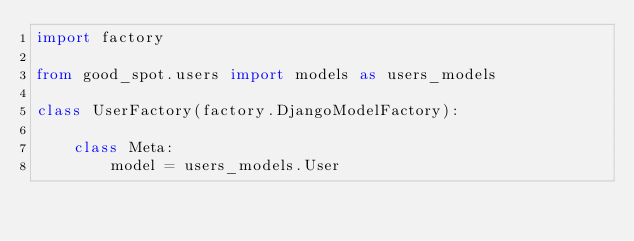<code> <loc_0><loc_0><loc_500><loc_500><_Python_>import factory

from good_spot.users import models as users_models

class UserFactory(factory.DjangoModelFactory):

    class Meta:
        model = users_models.User</code> 